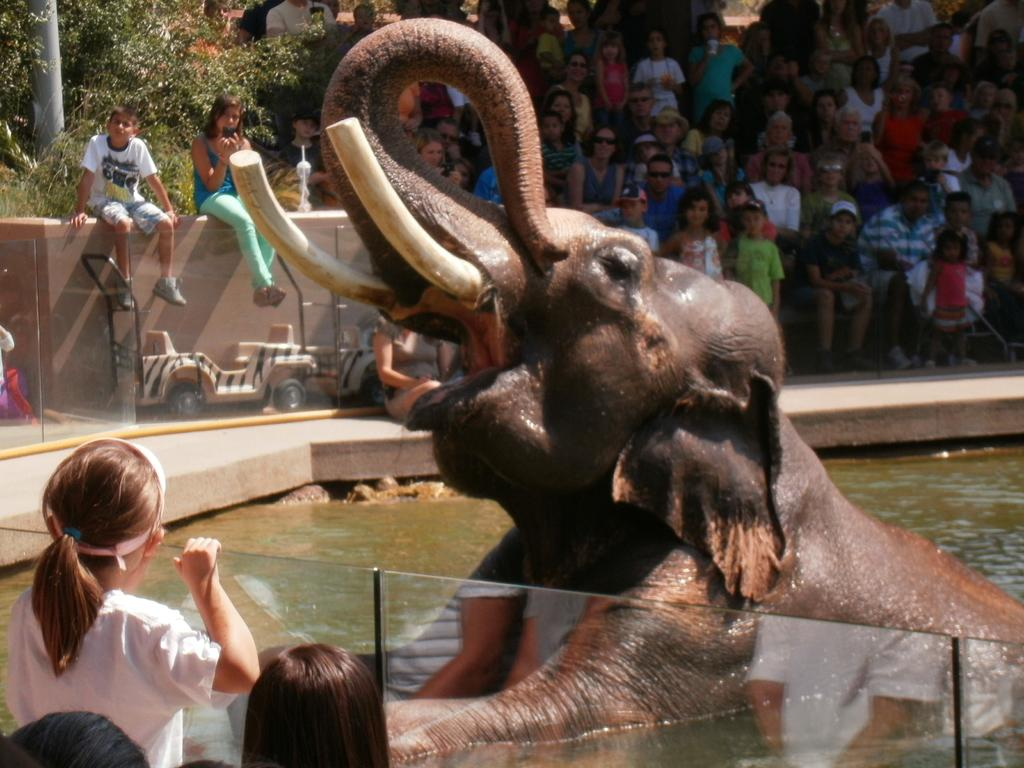What is the person in the image holding? The person is holding a paintbrush. What is the person doing with the paintbrush? The person is painting on a canvas. Where is the person sitting while painting? The person is sitting on a bench. What is the location of the bench? The bench is in a park. How many cakes does the person have on their plate in the image? There are no cakes present in the image; the person is holding a paintbrush and painting on a canvas. 